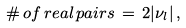<formula> <loc_0><loc_0><loc_500><loc_500>\# \, o f \, r e a l \, p a i r s \, = \, 2 | \nu _ { l } | \, ,</formula> 